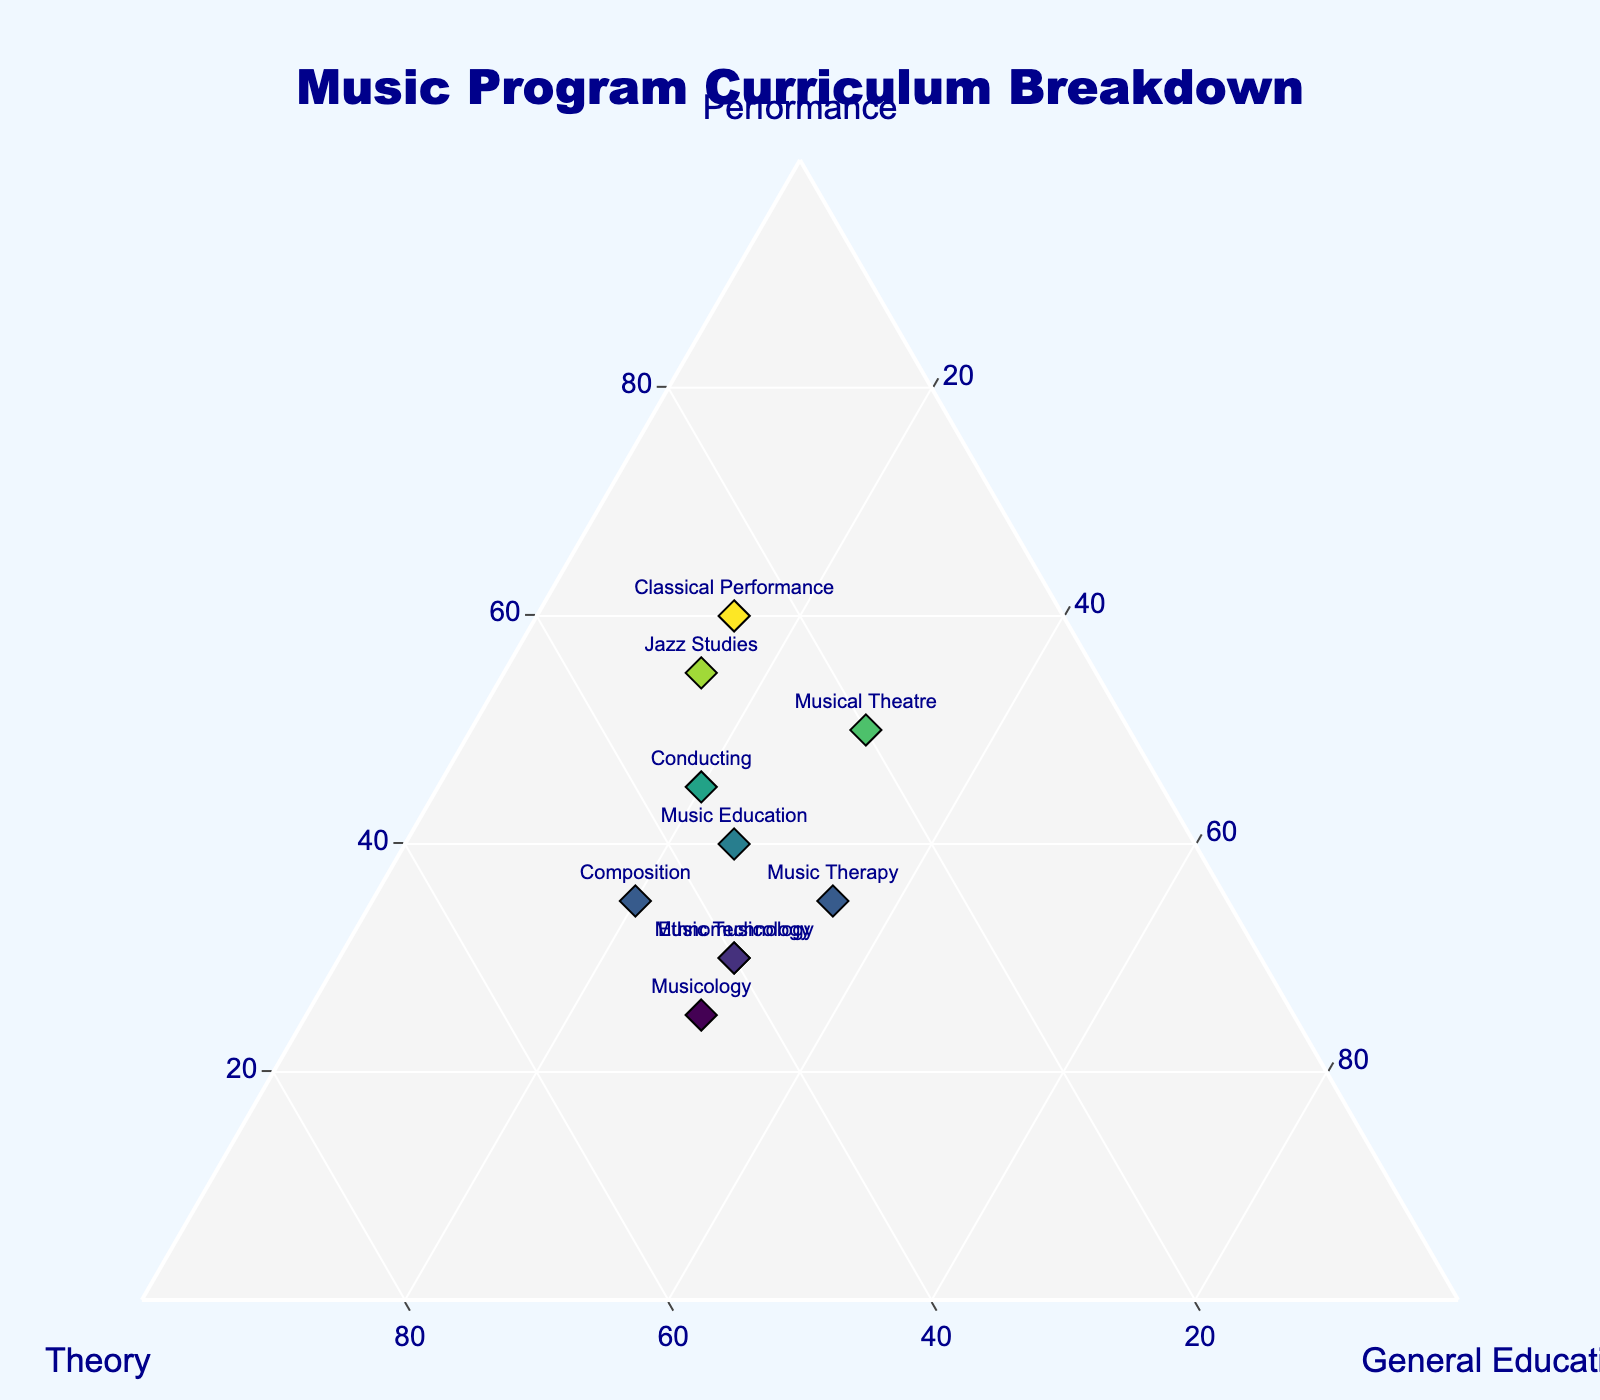How many data points are there in the figure? By counting the number of programs listed (each representing a data point), you can determine the total number of data points in the ternary plot.
Answer: 10 What is the title of the figure? The title can be found at the top of the figure, usually in a larger font size to stand out. It provides a brief description of the content.
Answer: Music Program Curriculum Breakdown Which program has the highest percentage of performance classes? Look for the data point that is located furthest towards the 'Performance' vertex of the ternary plot (this is typically indicated by the axis labels in a ternary plot). Check the corresponding text label for the program.
Answer: Classical Performance What is the combined percentage of music theory and general education classes for the Jazz Studies program? Identify the Jazz Studies point on the plot and read off its music theory (30) and general education (15) percentages. Add these two numbers together.
Answer: 45 Which two programs have an equal percentage of general education classes? Examine the position of the data points along the 'General Education' axis. Two programs have a value of 30% for general education: Music Technology and Ethnomusicology.
Answer: Music Technology and Ethnomusicology Which program has the most balanced curriculum across performance, theory, and general education? To find the most balanced program, look for a point that lies closest to the center of the ternary plot where the percentages for performance, theory, and general education are roughly equal.
Answer: Music Therapy Is there a program that has more than double the percentage of performance classes compared to general education classes? Compare the percentages of performance and general education classes for each program. The Classical Performance program has 60% performance and 15% general education, which is more than double.
Answer: Yes, Classical Performance On which axis is the percentage of theory classes represented? Each ternary plot has three axes, one for each component. Identify which axis corresponds to the theory classes by looking at the axis titles.
Answer: Bottom-left axis What is the range of the percentages for performance classes among all programs? Identify the minimum and maximum percentages of performance classes among all data points in the plot. The lowest is 25% (Musicology), and the highest is 60% (Classical Performance). The range is 60 - 25.
Answer: 35 Which program lies closest to the 'General Education' vertex of the ternary plot? The program with the highest percentage of general education classes will be closest to the 'General Education' vertex of the plot.
Answer: Music Therapy 